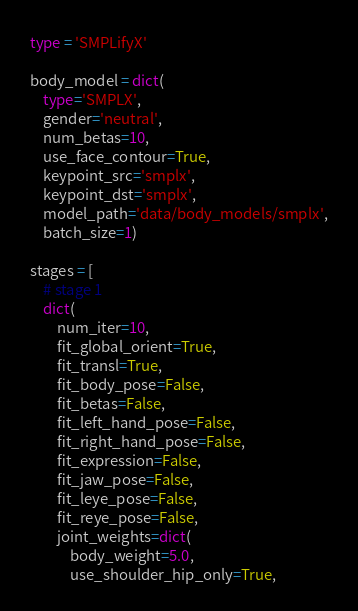<code> <loc_0><loc_0><loc_500><loc_500><_Python_>type = 'SMPLifyX'

body_model = dict(
    type='SMPLX',
    gender='neutral',
    num_betas=10,
    use_face_contour=True,
    keypoint_src='smplx',
    keypoint_dst='smplx',
    model_path='data/body_models/smplx',
    batch_size=1)

stages = [
    # stage 1
    dict(
        num_iter=10,
        fit_global_orient=True,
        fit_transl=True,
        fit_body_pose=False,
        fit_betas=False,
        fit_left_hand_pose=False,
        fit_right_hand_pose=False,
        fit_expression=False,
        fit_jaw_pose=False,
        fit_leye_pose=False,
        fit_reye_pose=False,
        joint_weights=dict(
            body_weight=5.0,
            use_shoulder_hip_only=True,</code> 